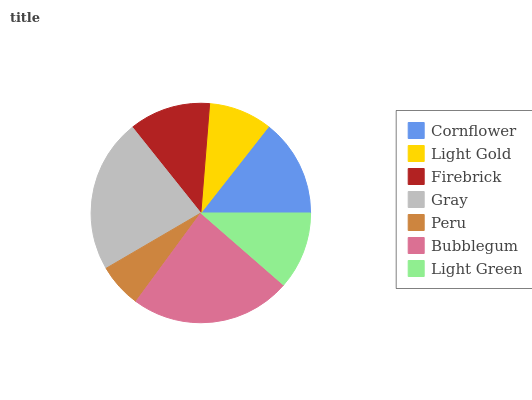Is Peru the minimum?
Answer yes or no. Yes. Is Bubblegum the maximum?
Answer yes or no. Yes. Is Light Gold the minimum?
Answer yes or no. No. Is Light Gold the maximum?
Answer yes or no. No. Is Cornflower greater than Light Gold?
Answer yes or no. Yes. Is Light Gold less than Cornflower?
Answer yes or no. Yes. Is Light Gold greater than Cornflower?
Answer yes or no. No. Is Cornflower less than Light Gold?
Answer yes or no. No. Is Firebrick the high median?
Answer yes or no. Yes. Is Firebrick the low median?
Answer yes or no. Yes. Is Light Green the high median?
Answer yes or no. No. Is Light Green the low median?
Answer yes or no. No. 